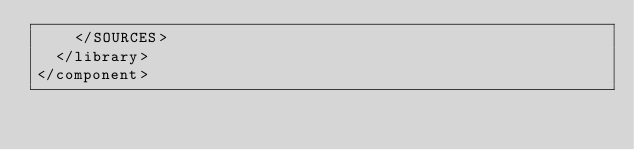Convert code to text. <code><loc_0><loc_0><loc_500><loc_500><_XML_>    </SOURCES>
  </library>
</component></code> 